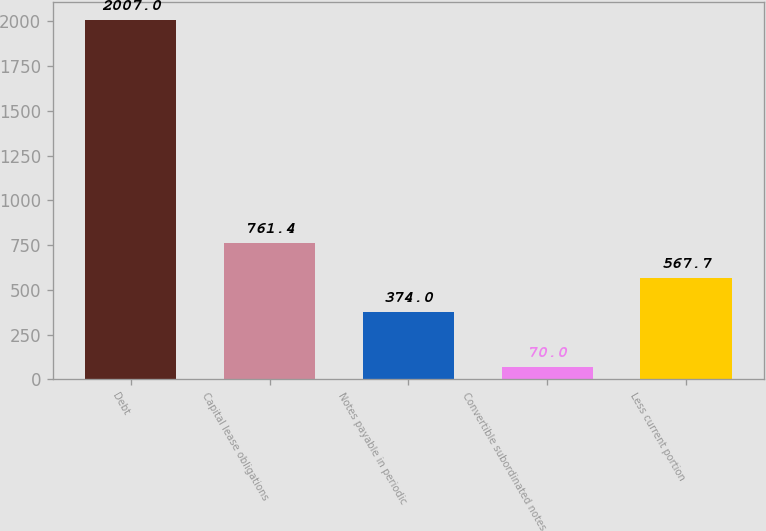Convert chart to OTSL. <chart><loc_0><loc_0><loc_500><loc_500><bar_chart><fcel>Debt<fcel>Capital lease obligations<fcel>Notes payable in periodic<fcel>Convertible subordinated notes<fcel>Less current portion<nl><fcel>2007<fcel>761.4<fcel>374<fcel>70<fcel>567.7<nl></chart> 